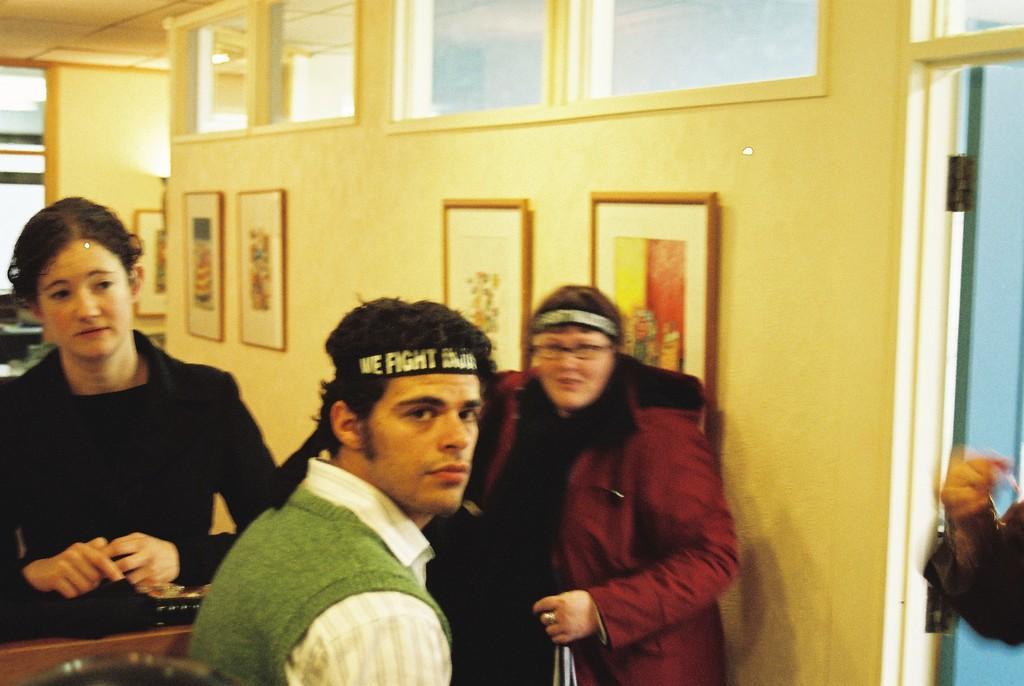In one or two sentences, can you explain what this image depicts? In the picture I can see three persons and there are few photo frames attached to the wall in the background and there is a hand of a person in the right corner. 